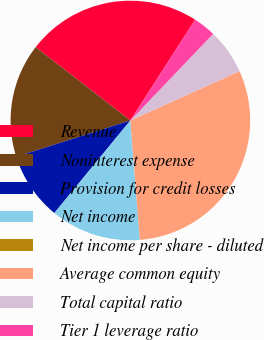Convert chart. <chart><loc_0><loc_0><loc_500><loc_500><pie_chart><fcel>Revenue<fcel>Noninterest expense<fcel>Provision for credit losses<fcel>Net income<fcel>Net income per share - diluted<fcel>Average common equity<fcel>Total capital ratio<fcel>Tier 1 leverage ratio<nl><fcel>23.6%<fcel>15.39%<fcel>9.15%<fcel>12.2%<fcel>0.0%<fcel>30.5%<fcel>6.1%<fcel>3.05%<nl></chart> 